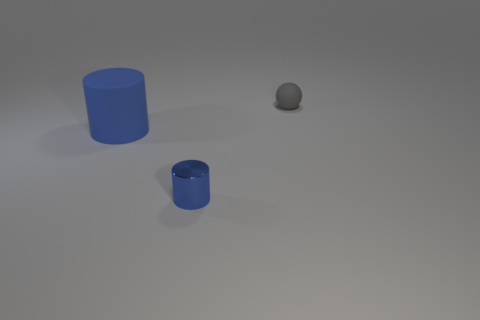Add 3 blue matte cylinders. How many objects exist? 6 Subtract all cylinders. How many objects are left? 1 Subtract 1 spheres. How many spheres are left? 0 Subtract all red spheres. Subtract all purple cubes. How many spheres are left? 1 Subtract all purple cubes. How many red cylinders are left? 0 Subtract all shiny blocks. Subtract all tiny metal things. How many objects are left? 2 Add 3 blue cylinders. How many blue cylinders are left? 5 Add 3 gray metal blocks. How many gray metal blocks exist? 3 Subtract 0 green cubes. How many objects are left? 3 